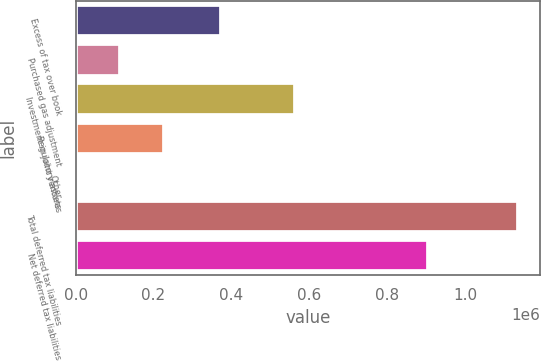Convert chart. <chart><loc_0><loc_0><loc_500><loc_500><bar_chart><fcel>Excess of tax over book<fcel>Purchased gas adjustment<fcel>Investment in joint ventures<fcel>Regulatory assets<fcel>Other<fcel>Total deferred tax liabilities<fcel>Net deferred tax liabilities<nl><fcel>372123<fcel>114390<fcel>564234<fcel>228034<fcel>746<fcel>1.13719e+06<fcel>904216<nl></chart> 